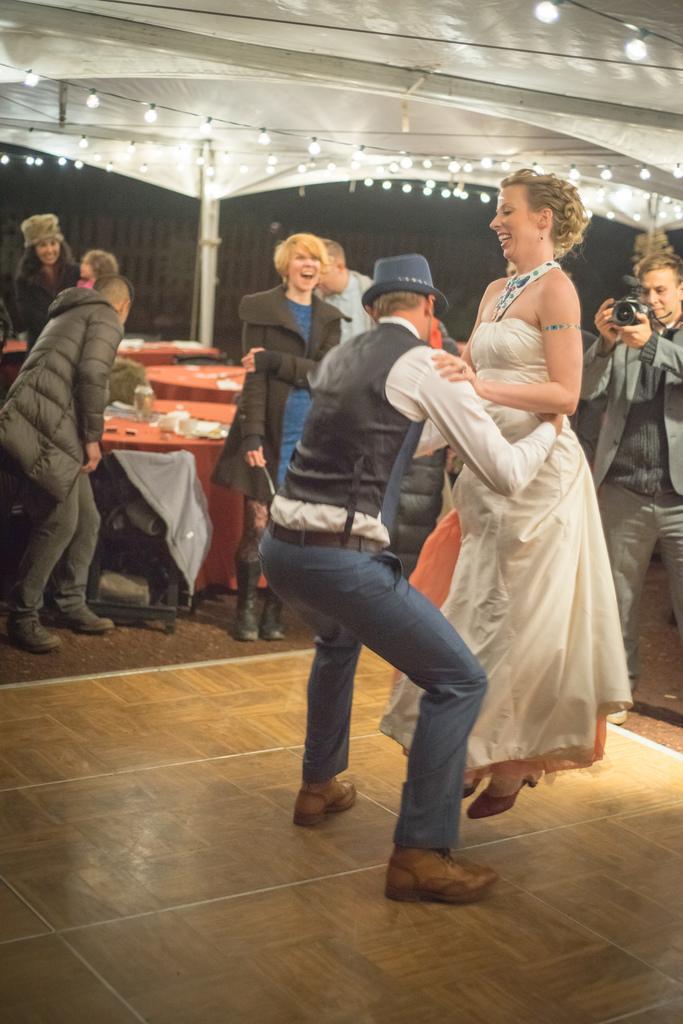In one or two sentences, can you explain what this image depicts? In this picture there is a man and a woman on the right side of the image, they are dancing and there are other people in the background area of the image, there are lights at the top side of the image. 